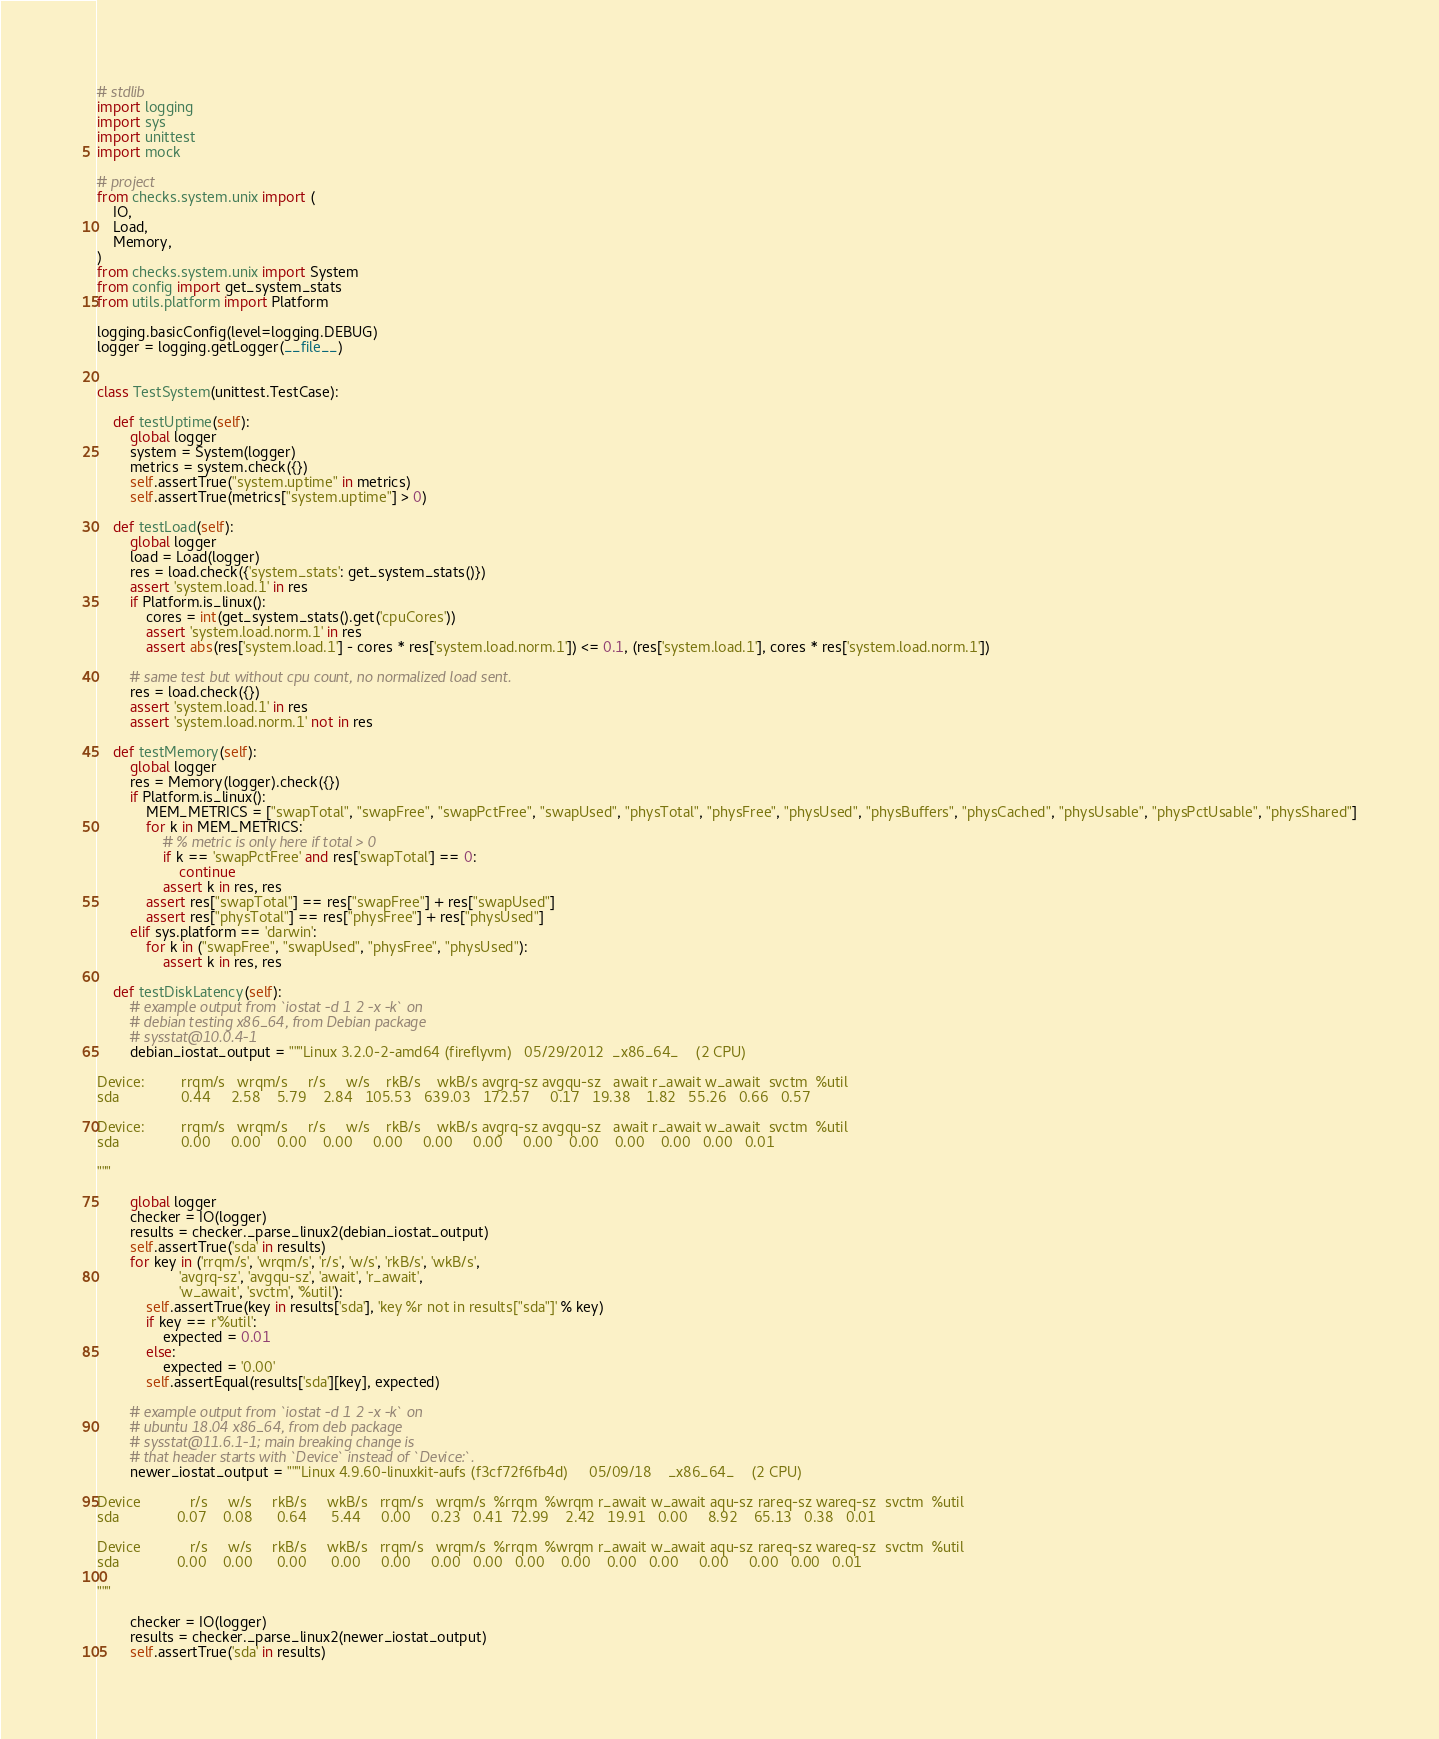Convert code to text. <code><loc_0><loc_0><loc_500><loc_500><_Python_># stdlib
import logging
import sys
import unittest
import mock

# project
from checks.system.unix import (
    IO,
    Load,
    Memory,
)
from checks.system.unix import System
from config import get_system_stats
from utils.platform import Platform

logging.basicConfig(level=logging.DEBUG)
logger = logging.getLogger(__file__)


class TestSystem(unittest.TestCase):

    def testUptime(self):
        global logger
        system = System(logger)
        metrics = system.check({})
        self.assertTrue("system.uptime" in metrics)
        self.assertTrue(metrics["system.uptime"] > 0)

    def testLoad(self):
        global logger
        load = Load(logger)
        res = load.check({'system_stats': get_system_stats()})
        assert 'system.load.1' in res
        if Platform.is_linux():
            cores = int(get_system_stats().get('cpuCores'))
            assert 'system.load.norm.1' in res
            assert abs(res['system.load.1'] - cores * res['system.load.norm.1']) <= 0.1, (res['system.load.1'], cores * res['system.load.norm.1'])

        # same test but without cpu count, no normalized load sent.
        res = load.check({})
        assert 'system.load.1' in res
        assert 'system.load.norm.1' not in res

    def testMemory(self):
        global logger
        res = Memory(logger).check({})
        if Platform.is_linux():
            MEM_METRICS = ["swapTotal", "swapFree", "swapPctFree", "swapUsed", "physTotal", "physFree", "physUsed", "physBuffers", "physCached", "physUsable", "physPctUsable", "physShared"]
            for k in MEM_METRICS:
                # % metric is only here if total > 0
                if k == 'swapPctFree' and res['swapTotal'] == 0:
                    continue
                assert k in res, res
            assert res["swapTotal"] == res["swapFree"] + res["swapUsed"]
            assert res["physTotal"] == res["physFree"] + res["physUsed"]
        elif sys.platform == 'darwin':
            for k in ("swapFree", "swapUsed", "physFree", "physUsed"):
                assert k in res, res

    def testDiskLatency(self):
        # example output from `iostat -d 1 2 -x -k` on
        # debian testing x86_64, from Debian package
        # sysstat@10.0.4-1
        debian_iostat_output = """Linux 3.2.0-2-amd64 (fireflyvm)   05/29/2012  _x86_64_    (2 CPU)

Device:         rrqm/s   wrqm/s     r/s     w/s    rkB/s    wkB/s avgrq-sz avgqu-sz   await r_await w_await  svctm  %util
sda               0.44     2.58    5.79    2.84   105.53   639.03   172.57     0.17   19.38    1.82   55.26   0.66   0.57

Device:         rrqm/s   wrqm/s     r/s     w/s    rkB/s    wkB/s avgrq-sz avgqu-sz   await r_await w_await  svctm  %util
sda               0.00     0.00    0.00    0.00     0.00     0.00     0.00     0.00    0.00    0.00    0.00   0.00   0.01

"""

        global logger
        checker = IO(logger)
        results = checker._parse_linux2(debian_iostat_output)
        self.assertTrue('sda' in results)
        for key in ('rrqm/s', 'wrqm/s', 'r/s', 'w/s', 'rkB/s', 'wkB/s',
                    'avgrq-sz', 'avgqu-sz', 'await', 'r_await',
                    'w_await', 'svctm', '%util'):
            self.assertTrue(key in results['sda'], 'key %r not in results["sda"]' % key)
            if key == r'%util':
                expected = 0.01
            else:
                expected = '0.00'
            self.assertEqual(results['sda'][key], expected)

        # example output from `iostat -d 1 2 -x -k` on
        # ubuntu 18.04 x86_64, from deb package
        # sysstat@11.6.1-1; main breaking change is
        # that header starts with `Device` instead of `Device:`.
        newer_iostat_output = """Linux 4.9.60-linuxkit-aufs (f3cf72f6fb4d)     05/09/18    _x86_64_    (2 CPU)

Device            r/s     w/s     rkB/s     wkB/s   rrqm/s   wrqm/s  %rrqm  %wrqm r_await w_await aqu-sz rareq-sz wareq-sz  svctm  %util
sda              0.07    0.08      0.64      5.44     0.00     0.23   0.41  72.99    2.42   19.91   0.00     8.92    65.13   0.38   0.01

Device            r/s     w/s     rkB/s     wkB/s   rrqm/s   wrqm/s  %rrqm  %wrqm r_await w_await aqu-sz rareq-sz wareq-sz  svctm  %util
sda              0.00    0.00      0.00      0.00     0.00     0.00   0.00   0.00    0.00    0.00   0.00     0.00     0.00   0.00   0.01

"""

        checker = IO(logger)
        results = checker._parse_linux2(newer_iostat_output)
        self.assertTrue('sda' in results)</code> 